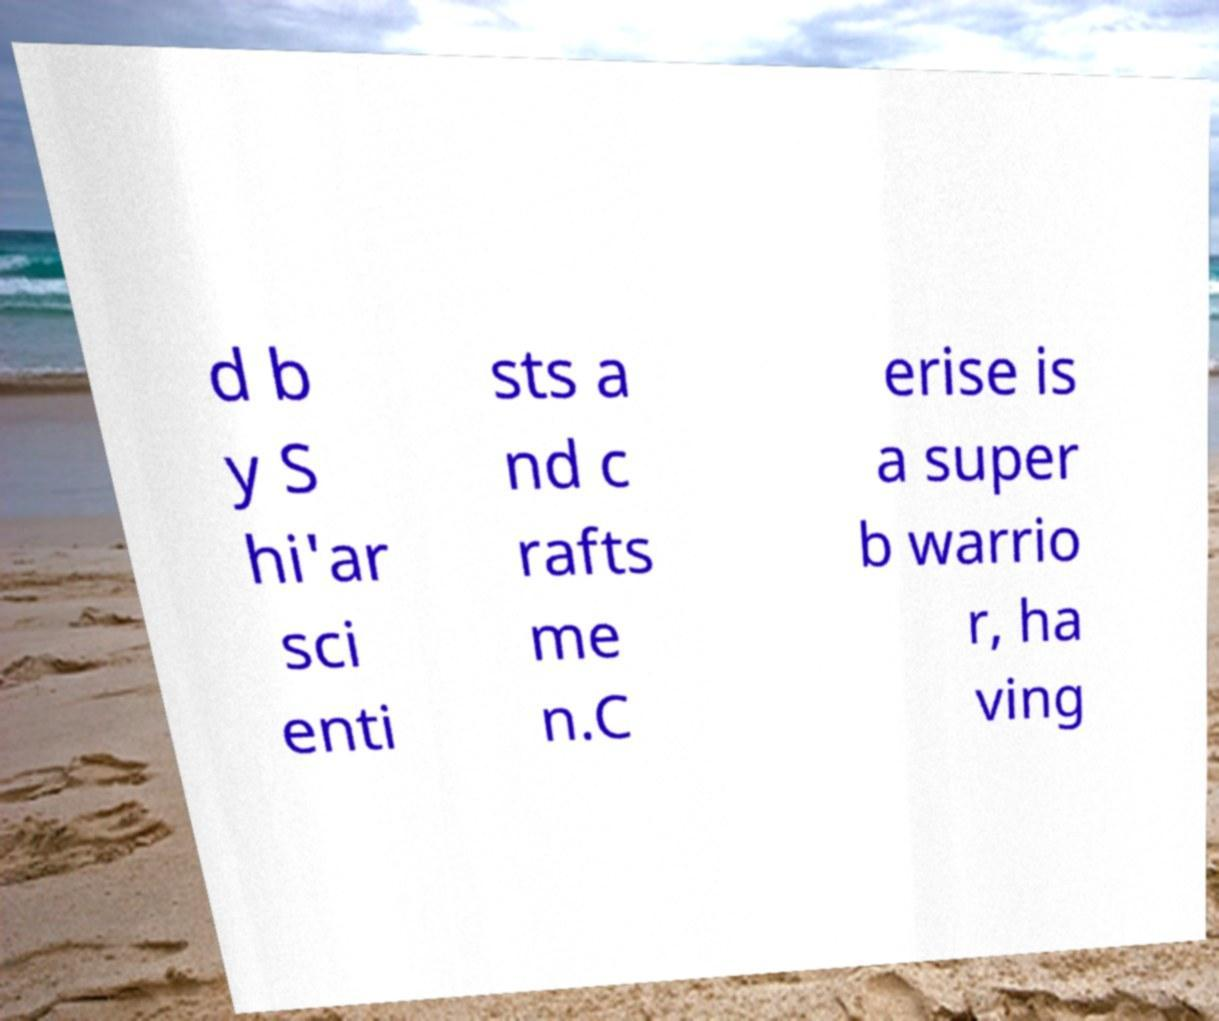There's text embedded in this image that I need extracted. Can you transcribe it verbatim? d b y S hi'ar sci enti sts a nd c rafts me n.C erise is a super b warrio r, ha ving 